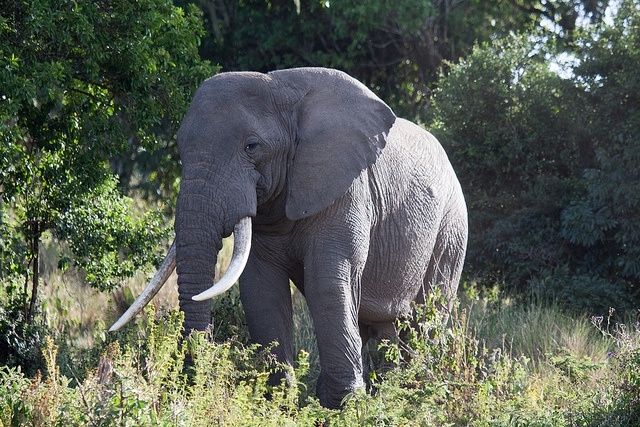Describe the objects in this image and their specific colors. I can see a elephant in black, gray, and lightgray tones in this image. 